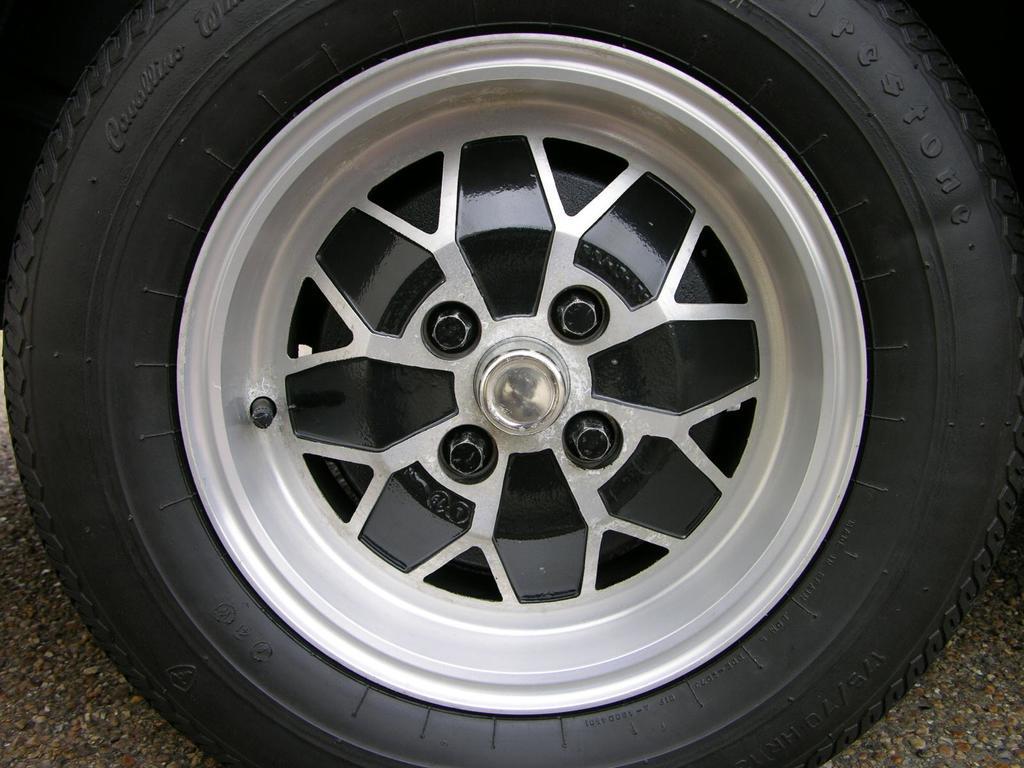Could you give a brief overview of what you see in this image? In this picture I can see there is a wheel on the road and it has threads and a name, there are few bolts and a rim. 